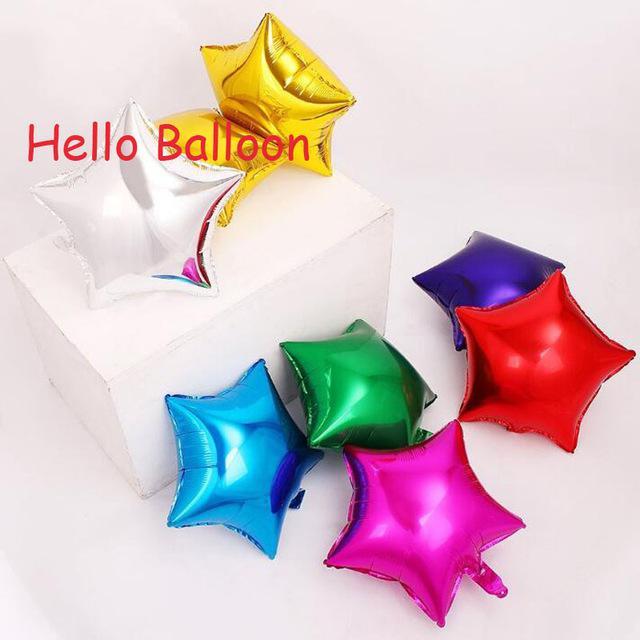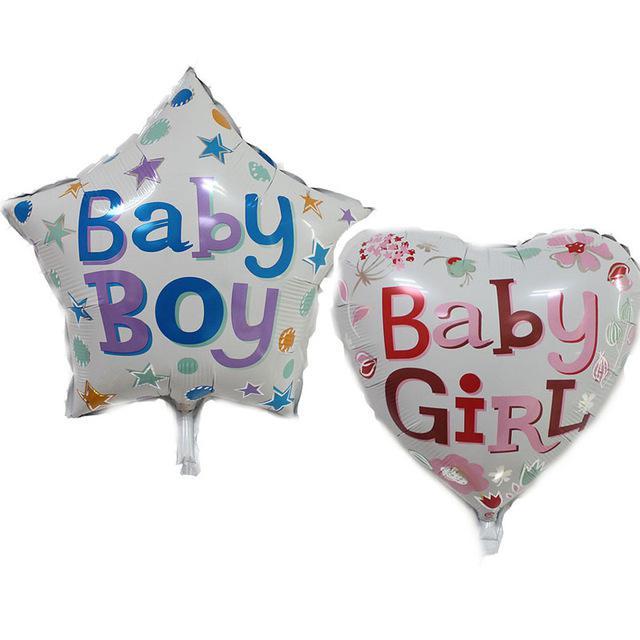The first image is the image on the left, the second image is the image on the right. Assess this claim about the two images: "IN at least one image there is a single star balloon.". Correct or not? Answer yes or no. Yes. The first image is the image on the left, the second image is the image on the right. Analyze the images presented: Is the assertion "Each image includes at least one star-shaped balloon, and at least one image includes multiple colors of star balloons, including gold, green, red, and blue." valid? Answer yes or no. Yes. 